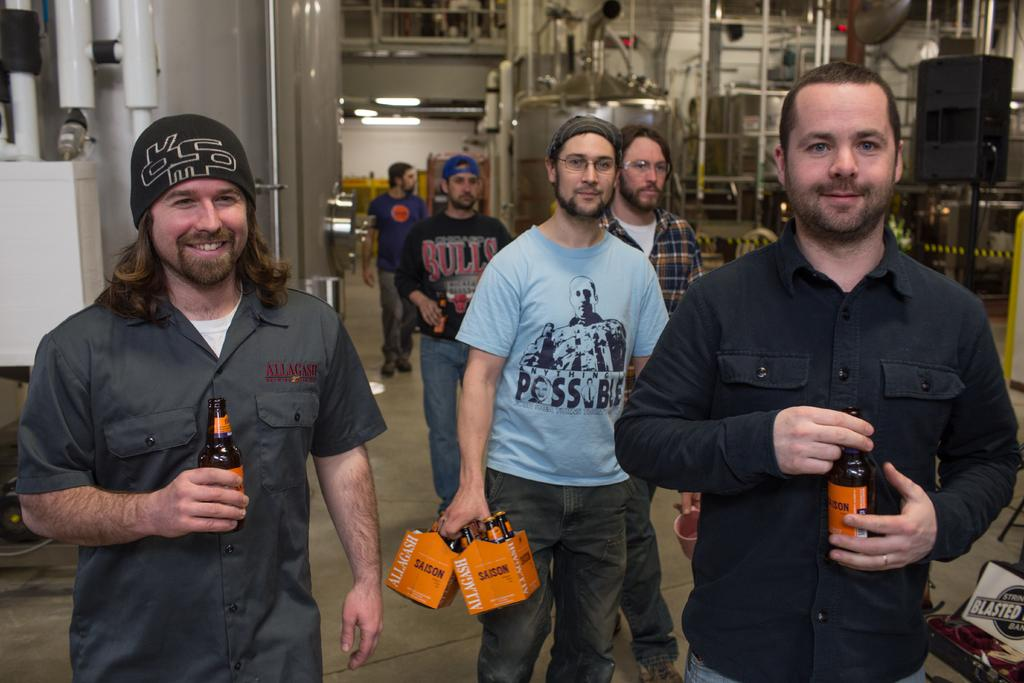How many people are in the image? There are multiple persons in the image. What are the persons holding in their hands? The persons are holding bottles in their hands. What can be seen in the background of the image? There are machines visible in the background of the image. What type of pet is being discussed by the persons in the image? There is no indication in the image that the persons are discussing a pet, as they are holding bottles and there are machines visible in the background. 